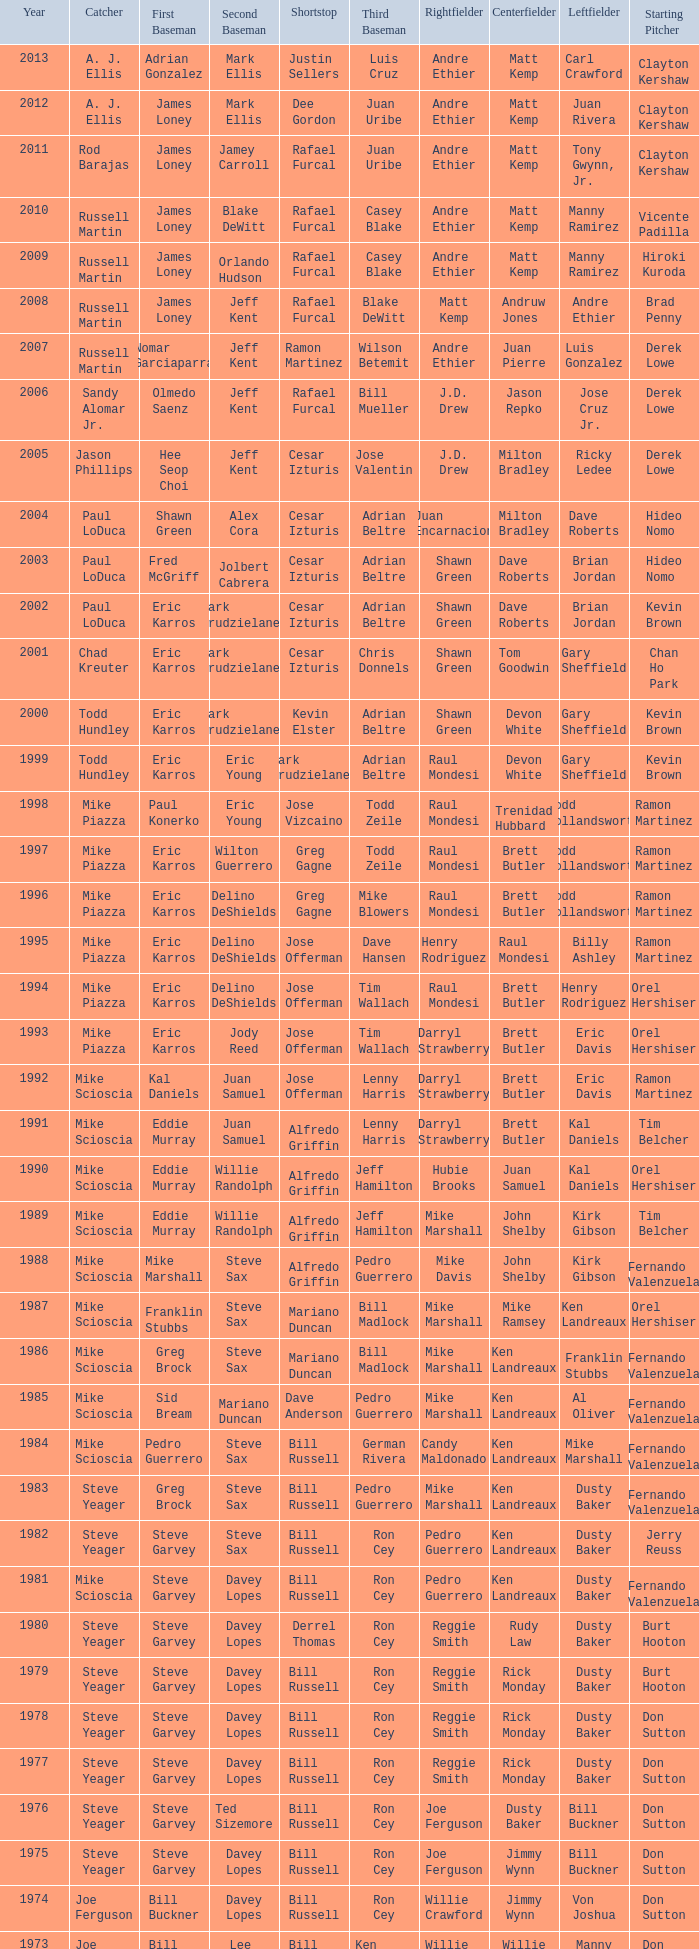With jim lefebvre at 2nd, willie davis in the center field, and don drysdale as the starting pitcher, who was the shortstop player? Maury Wills. 